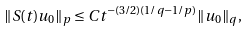<formula> <loc_0><loc_0><loc_500><loc_500>\| S ( t ) u _ { 0 } \| _ { p } \leq C t ^ { - ( 3 / 2 ) ( 1 / q - 1 / p ) } \| u _ { 0 } \| _ { q } ,</formula> 